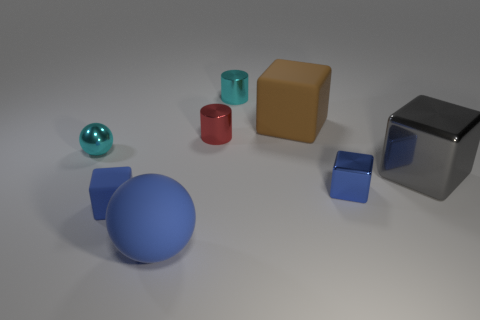Add 1 big metallic things. How many objects exist? 9 Subtract all balls. How many objects are left? 6 Subtract all matte spheres. Subtract all small shiny spheres. How many objects are left? 6 Add 7 tiny cyan balls. How many tiny cyan balls are left? 8 Add 4 tiny cyan balls. How many tiny cyan balls exist? 5 Subtract 1 blue spheres. How many objects are left? 7 